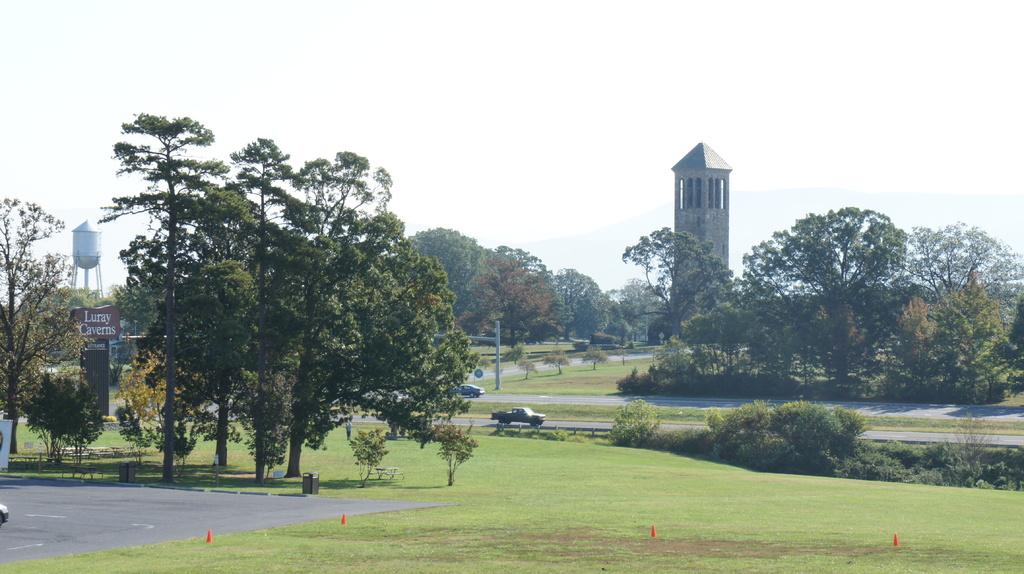What type of vegetation can be seen in the image? There are trees, grass, and plants in the image. What structure is present in the image? There is a tower in the image. What type of vehicle can be seen in the image? There is a vehicle in the image. What type of surface is visible in the image? There are roads in the image. What type of container is present in the image? There are bins in the image. What type of military equipment is present in the image? There is a tank in the image. What type of pole is present in the image? There is a pole in the image. What is visible in the sky in the image? The sky is visible in the image. What type of object is present in the image? There are boards and objects in the image. Is there any writing visible on one of the boards? Yes, something is written on one of the boards. Can you see a mitten hanging on the pole in the image? No, there is no mitten present in the image. Is the father of the person who took the photo visible in the image? There is no indication of the photographer's father in the image. 